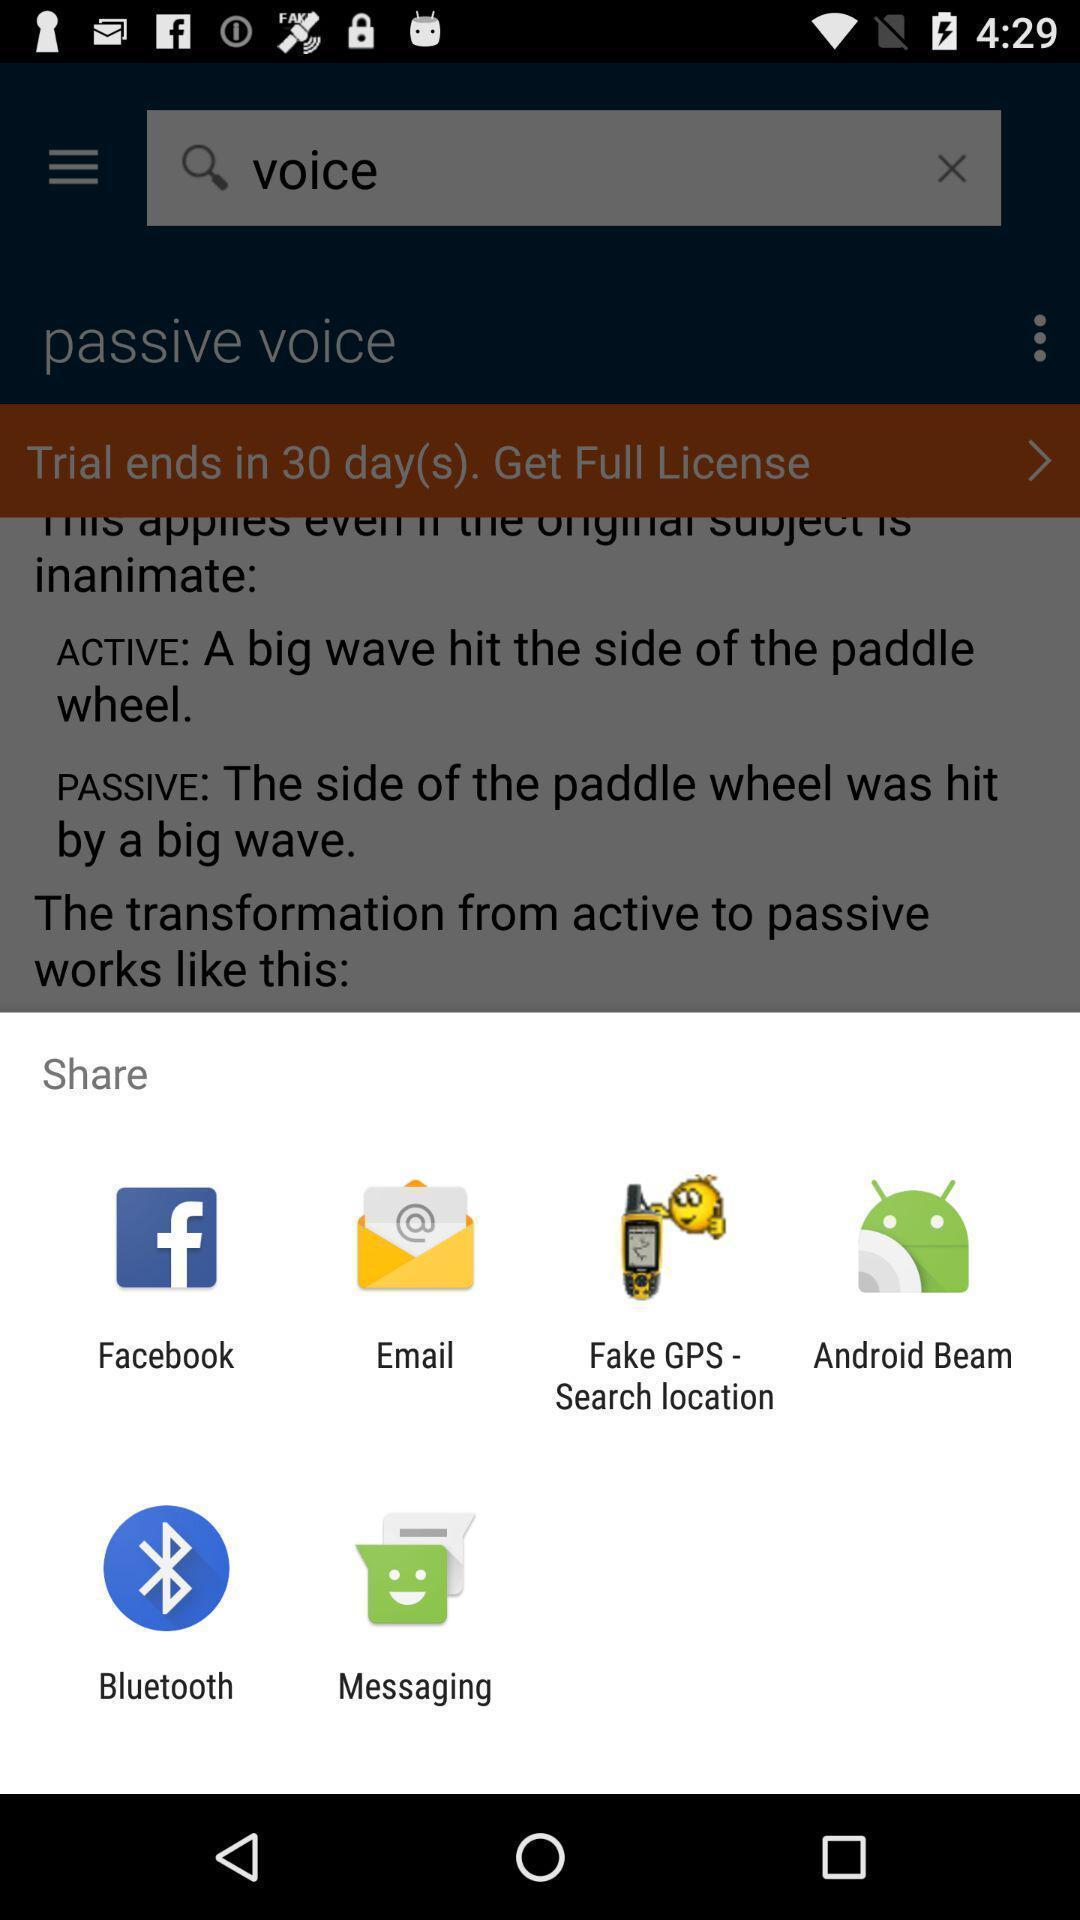Describe this image in words. Share options page of an english grammar app. 